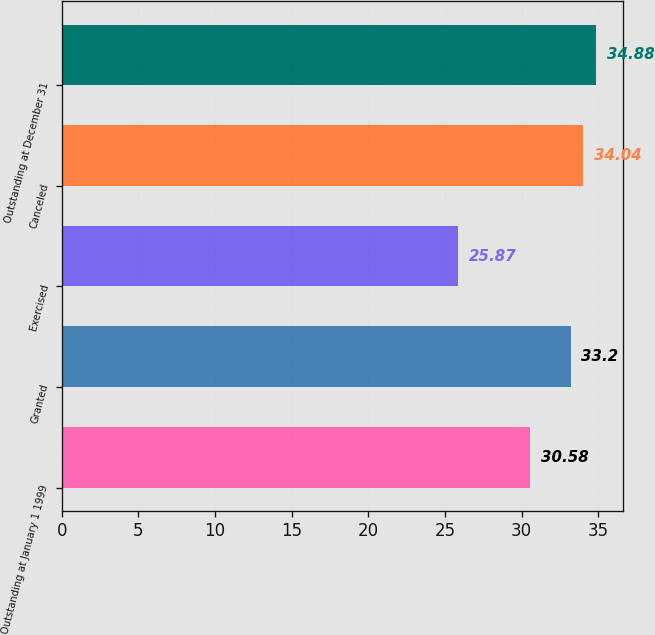<chart> <loc_0><loc_0><loc_500><loc_500><bar_chart><fcel>Outstanding at January 1 1999<fcel>Granted<fcel>Exercised<fcel>Canceled<fcel>Outstanding at December 31<nl><fcel>30.58<fcel>33.2<fcel>25.87<fcel>34.04<fcel>34.88<nl></chart> 